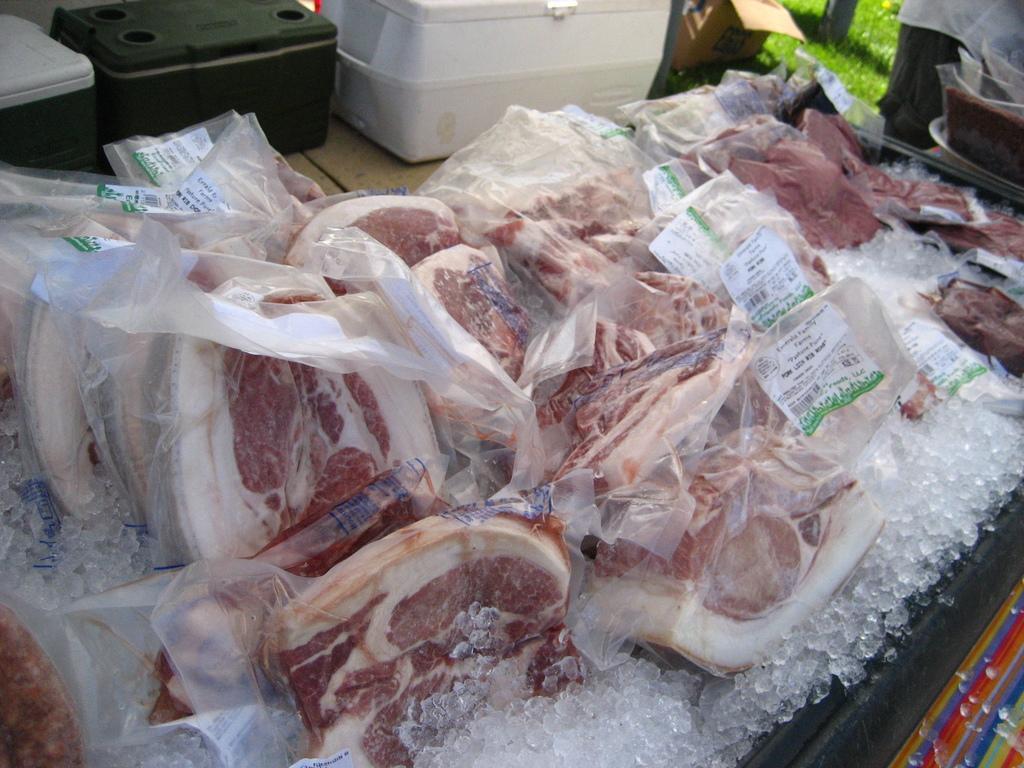In one or two sentences, can you explain what this image depicts? In this image at front there is meat on the table. Beside the meat there are three boxes. 